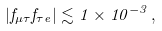<formula> <loc_0><loc_0><loc_500><loc_500>| f _ { \mu \tau } f _ { \tau e } | \lesssim 1 \times 1 0 ^ { - 3 } \, ,</formula> 